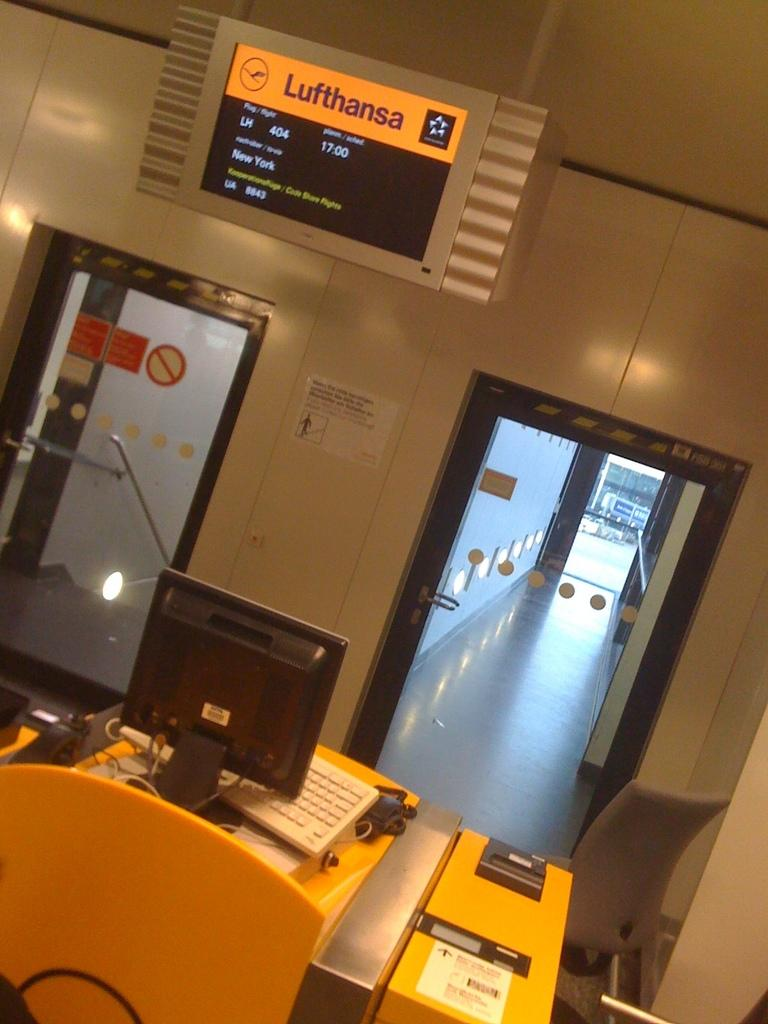<image>
Relay a brief, clear account of the picture shown. A doorway in an airport terminal at the Lufthansa gate. 